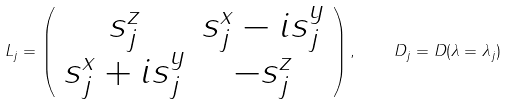Convert formula to latex. <formula><loc_0><loc_0><loc_500><loc_500>L _ { j } = \left ( \begin{array} { c c } s ^ { z } _ { j } & s ^ { x } _ { j } - i s ^ { y } _ { j } \\ s ^ { x } _ { j } + i s ^ { y } _ { j } & - s ^ { z } _ { j } \end{array} \right ) , \quad D _ { j } = D ( \lambda = \lambda _ { j } )</formula> 